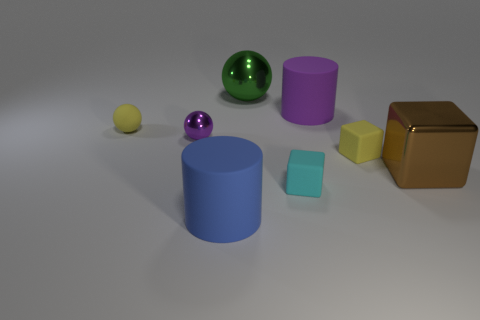What is the size of the object that is the same color as the matte ball?
Your answer should be very brief. Small. What number of other objects are there of the same size as the yellow ball?
Your answer should be very brief. 3. Are the cylinder that is behind the large blue object and the small cyan object made of the same material?
Keep it short and to the point. Yes. How many other things are the same color as the big shiny block?
Offer a very short reply. 0. How many other objects are the same shape as the big brown shiny object?
Keep it short and to the point. 2. Is the shape of the small yellow rubber thing that is to the right of the large blue matte thing the same as the large shiny object in front of the purple ball?
Offer a very short reply. Yes. Is the number of small yellow cubes in front of the large brown cube the same as the number of large rubber cylinders that are right of the large green metal sphere?
Give a very brief answer. No. What shape is the yellow rubber object that is in front of the yellow object on the left side of the tiny yellow object that is to the right of the big purple cylinder?
Make the answer very short. Cube. Does the purple object that is on the left side of the large purple cylinder have the same material as the sphere that is on the right side of the blue matte cylinder?
Your answer should be very brief. Yes. The large metal thing to the left of the large brown object has what shape?
Ensure brevity in your answer.  Sphere. 